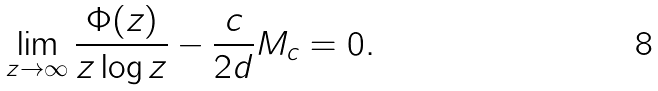Convert formula to latex. <formula><loc_0><loc_0><loc_500><loc_500>\lim _ { z \rightarrow \infty } \frac { \Phi ( z ) } { z \log z } - \frac { c } { 2 d } M _ { c } = 0 .</formula> 